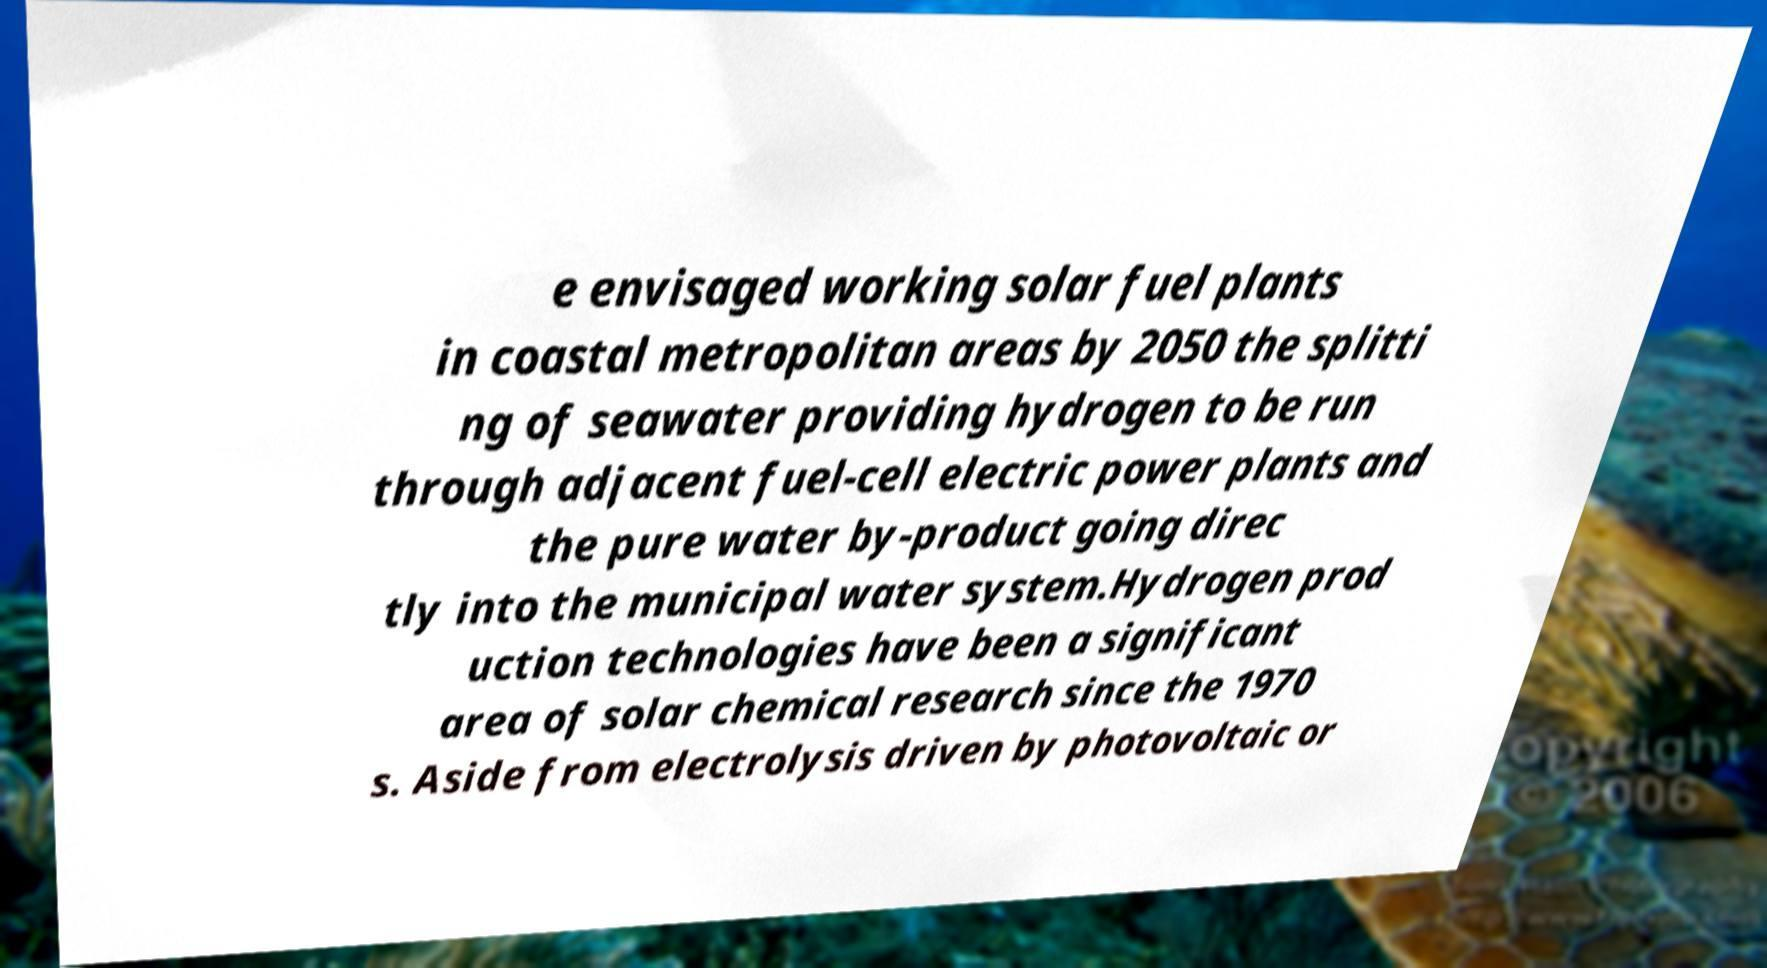Could you assist in decoding the text presented in this image and type it out clearly? e envisaged working solar fuel plants in coastal metropolitan areas by 2050 the splitti ng of seawater providing hydrogen to be run through adjacent fuel-cell electric power plants and the pure water by-product going direc tly into the municipal water system.Hydrogen prod uction technologies have been a significant area of solar chemical research since the 1970 s. Aside from electrolysis driven by photovoltaic or 